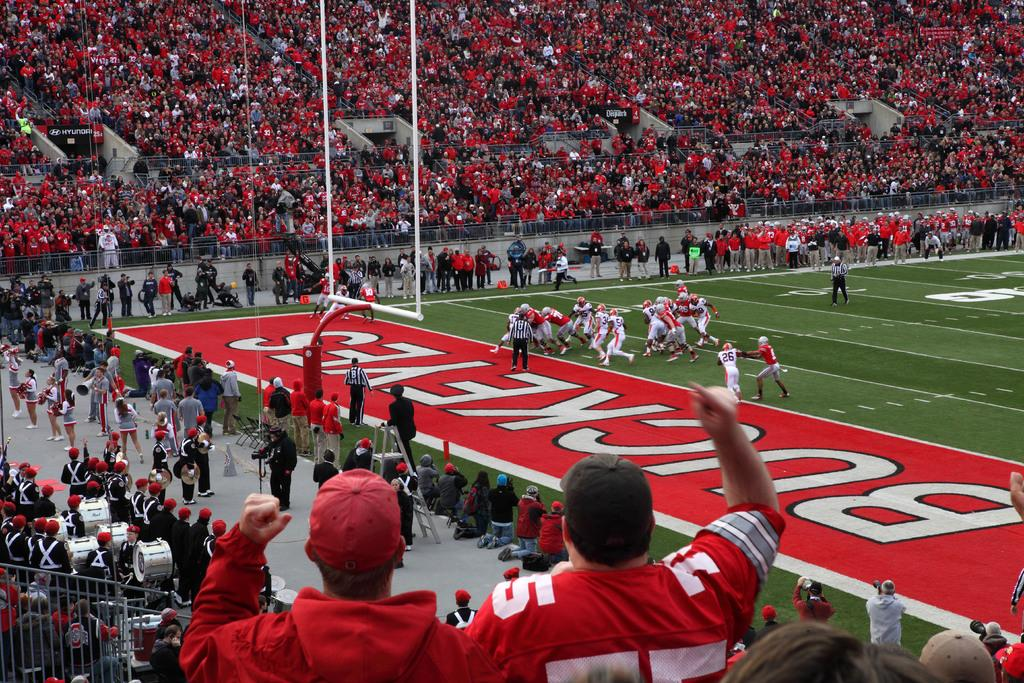<image>
Relay a brief, clear account of the picture shown. a football field that says 'buckeyes' on it 